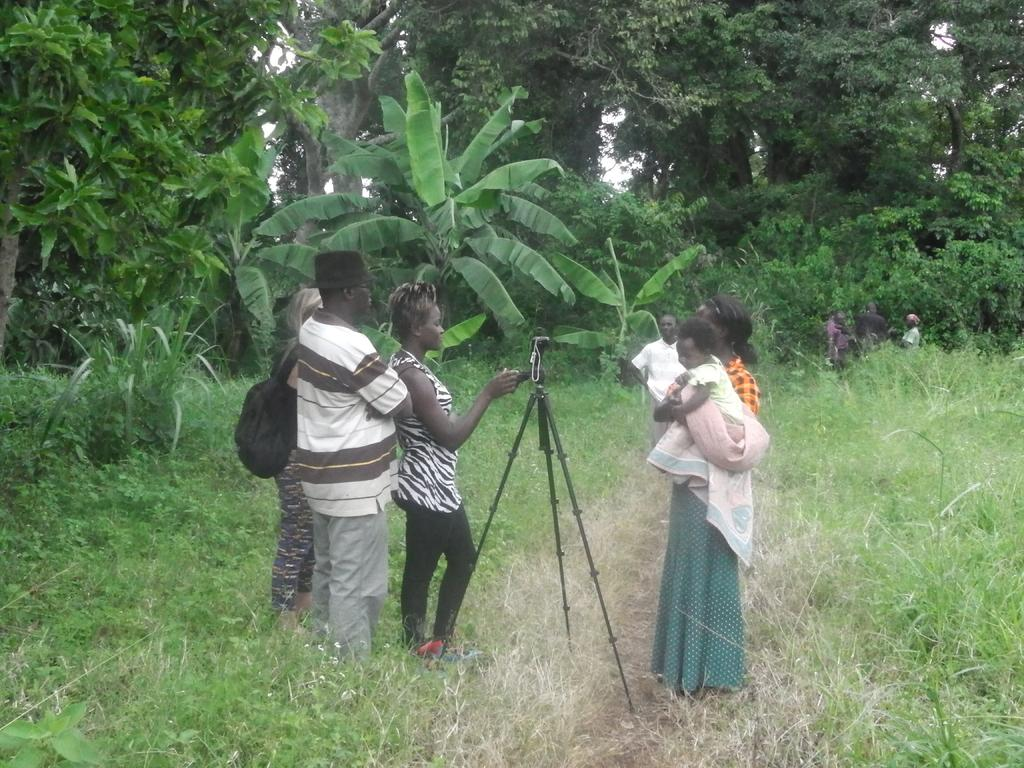Who or what is present in the image? There are people in the image. What object related to photography can be seen in the image? There is a camera stand in the image. What type of terrain is visible in the image? There is grass visible in the image. What can be seen in the distance in the image? There are trees in the background of the image. What type of debt is being discussed by the people in the image? There is no indication of any debt being discussed in the image; the focus is on the people, camera stand, grass, and trees. 